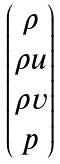<formula> <loc_0><loc_0><loc_500><loc_500>\begin{pmatrix} \rho \\ \rho u \\ \rho v \\ p \end{pmatrix}</formula> 